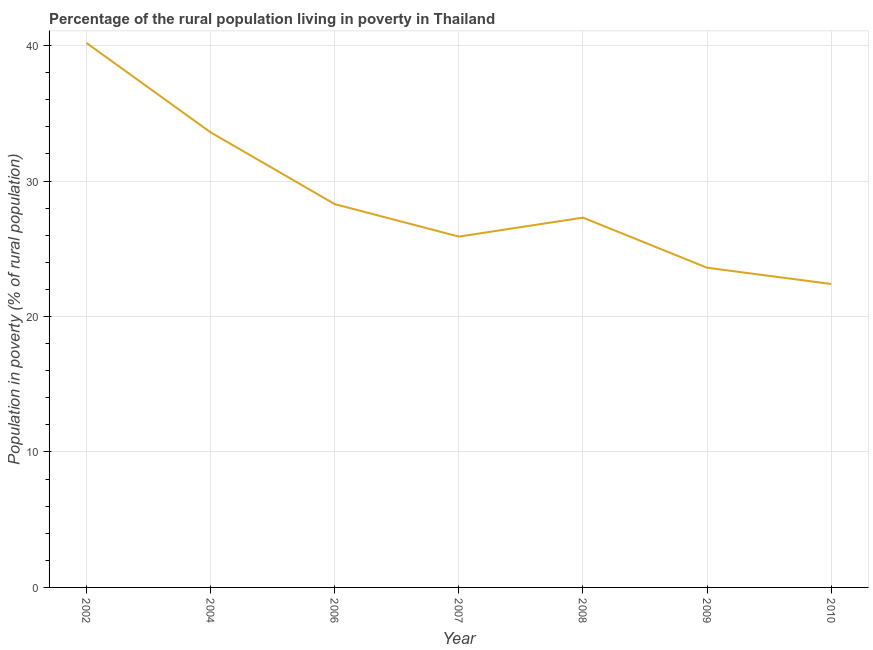What is the percentage of rural population living below poverty line in 2010?
Give a very brief answer. 22.4. Across all years, what is the maximum percentage of rural population living below poverty line?
Offer a very short reply. 40.2. Across all years, what is the minimum percentage of rural population living below poverty line?
Your response must be concise. 22.4. In which year was the percentage of rural population living below poverty line maximum?
Offer a terse response. 2002. In which year was the percentage of rural population living below poverty line minimum?
Provide a succinct answer. 2010. What is the sum of the percentage of rural population living below poverty line?
Your answer should be very brief. 201.3. What is the average percentage of rural population living below poverty line per year?
Your response must be concise. 28.76. What is the median percentage of rural population living below poverty line?
Your answer should be very brief. 27.3. In how many years, is the percentage of rural population living below poverty line greater than 30 %?
Your answer should be compact. 2. What is the ratio of the percentage of rural population living below poverty line in 2004 to that in 2006?
Ensure brevity in your answer.  1.19. What is the difference between the highest and the second highest percentage of rural population living below poverty line?
Provide a short and direct response. 6.6. Is the sum of the percentage of rural population living below poverty line in 2002 and 2004 greater than the maximum percentage of rural population living below poverty line across all years?
Ensure brevity in your answer.  Yes. What is the difference between the highest and the lowest percentage of rural population living below poverty line?
Offer a very short reply. 17.8. In how many years, is the percentage of rural population living below poverty line greater than the average percentage of rural population living below poverty line taken over all years?
Offer a terse response. 2. How many years are there in the graph?
Provide a short and direct response. 7. What is the difference between two consecutive major ticks on the Y-axis?
Your answer should be compact. 10. What is the title of the graph?
Keep it short and to the point. Percentage of the rural population living in poverty in Thailand. What is the label or title of the Y-axis?
Your answer should be compact. Population in poverty (% of rural population). What is the Population in poverty (% of rural population) of 2002?
Offer a very short reply. 40.2. What is the Population in poverty (% of rural population) of 2004?
Give a very brief answer. 33.6. What is the Population in poverty (% of rural population) of 2006?
Give a very brief answer. 28.3. What is the Population in poverty (% of rural population) in 2007?
Keep it short and to the point. 25.9. What is the Population in poverty (% of rural population) of 2008?
Offer a terse response. 27.3. What is the Population in poverty (% of rural population) in 2009?
Offer a very short reply. 23.6. What is the Population in poverty (% of rural population) of 2010?
Make the answer very short. 22.4. What is the difference between the Population in poverty (% of rural population) in 2002 and 2004?
Offer a terse response. 6.6. What is the difference between the Population in poverty (% of rural population) in 2002 and 2006?
Make the answer very short. 11.9. What is the difference between the Population in poverty (% of rural population) in 2002 and 2010?
Your response must be concise. 17.8. What is the difference between the Population in poverty (% of rural population) in 2004 and 2006?
Make the answer very short. 5.3. What is the difference between the Population in poverty (% of rural population) in 2004 and 2008?
Give a very brief answer. 6.3. What is the difference between the Population in poverty (% of rural population) in 2006 and 2008?
Ensure brevity in your answer.  1. What is the difference between the Population in poverty (% of rural population) in 2007 and 2009?
Provide a short and direct response. 2.3. What is the difference between the Population in poverty (% of rural population) in 2007 and 2010?
Offer a terse response. 3.5. What is the difference between the Population in poverty (% of rural population) in 2008 and 2010?
Ensure brevity in your answer.  4.9. What is the ratio of the Population in poverty (% of rural population) in 2002 to that in 2004?
Make the answer very short. 1.2. What is the ratio of the Population in poverty (% of rural population) in 2002 to that in 2006?
Your response must be concise. 1.42. What is the ratio of the Population in poverty (% of rural population) in 2002 to that in 2007?
Your answer should be compact. 1.55. What is the ratio of the Population in poverty (% of rural population) in 2002 to that in 2008?
Provide a short and direct response. 1.47. What is the ratio of the Population in poverty (% of rural population) in 2002 to that in 2009?
Keep it short and to the point. 1.7. What is the ratio of the Population in poverty (% of rural population) in 2002 to that in 2010?
Your response must be concise. 1.79. What is the ratio of the Population in poverty (% of rural population) in 2004 to that in 2006?
Your response must be concise. 1.19. What is the ratio of the Population in poverty (% of rural population) in 2004 to that in 2007?
Keep it short and to the point. 1.3. What is the ratio of the Population in poverty (% of rural population) in 2004 to that in 2008?
Give a very brief answer. 1.23. What is the ratio of the Population in poverty (% of rural population) in 2004 to that in 2009?
Make the answer very short. 1.42. What is the ratio of the Population in poverty (% of rural population) in 2004 to that in 2010?
Your response must be concise. 1.5. What is the ratio of the Population in poverty (% of rural population) in 2006 to that in 2007?
Provide a short and direct response. 1.09. What is the ratio of the Population in poverty (% of rural population) in 2006 to that in 2008?
Your response must be concise. 1.04. What is the ratio of the Population in poverty (% of rural population) in 2006 to that in 2009?
Your response must be concise. 1.2. What is the ratio of the Population in poverty (% of rural population) in 2006 to that in 2010?
Provide a succinct answer. 1.26. What is the ratio of the Population in poverty (% of rural population) in 2007 to that in 2008?
Offer a very short reply. 0.95. What is the ratio of the Population in poverty (% of rural population) in 2007 to that in 2009?
Make the answer very short. 1.1. What is the ratio of the Population in poverty (% of rural population) in 2007 to that in 2010?
Give a very brief answer. 1.16. What is the ratio of the Population in poverty (% of rural population) in 2008 to that in 2009?
Your response must be concise. 1.16. What is the ratio of the Population in poverty (% of rural population) in 2008 to that in 2010?
Give a very brief answer. 1.22. What is the ratio of the Population in poverty (% of rural population) in 2009 to that in 2010?
Make the answer very short. 1.05. 